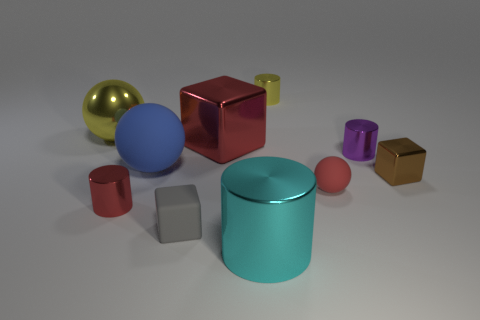Which object stands out the most due to its color? The red cylinder immediately draws the eye due to its vibrant and striking color in contrast to the more subdued colors of the surrounding objects. 